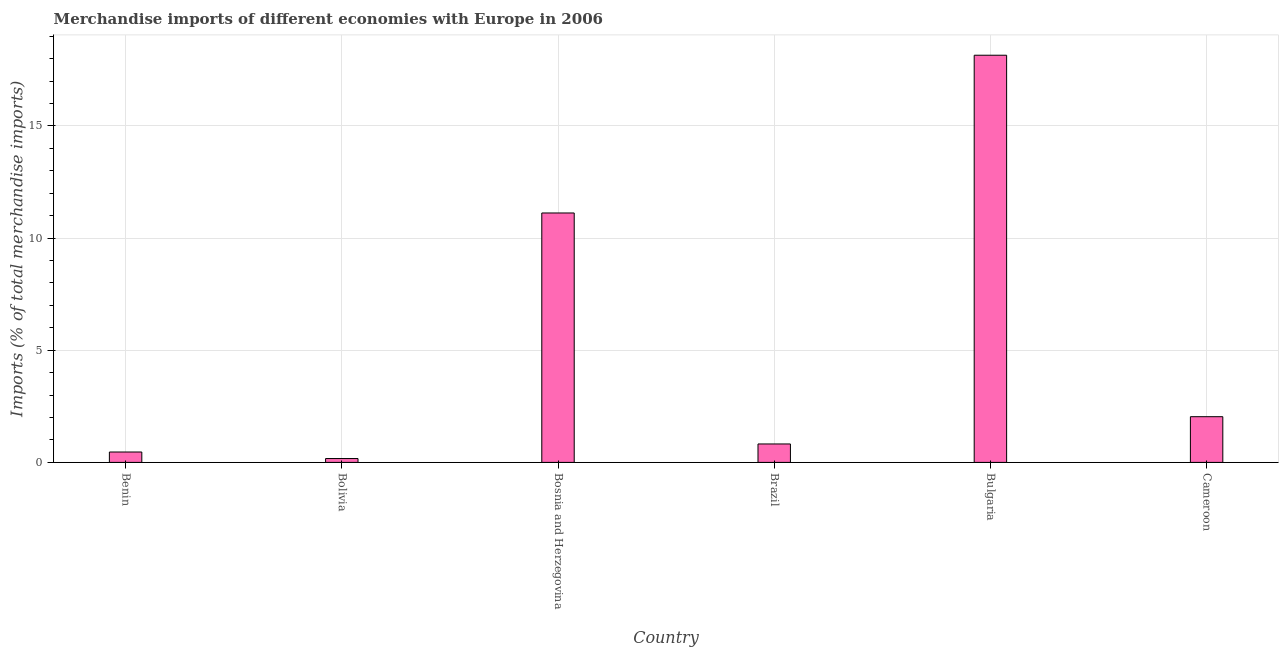What is the title of the graph?
Your response must be concise. Merchandise imports of different economies with Europe in 2006. What is the label or title of the X-axis?
Offer a very short reply. Country. What is the label or title of the Y-axis?
Keep it short and to the point. Imports (% of total merchandise imports). What is the merchandise imports in Bolivia?
Your answer should be very brief. 0.17. Across all countries, what is the maximum merchandise imports?
Make the answer very short. 18.15. Across all countries, what is the minimum merchandise imports?
Your answer should be very brief. 0.17. In which country was the merchandise imports maximum?
Your response must be concise. Bulgaria. What is the sum of the merchandise imports?
Make the answer very short. 32.77. What is the difference between the merchandise imports in Bolivia and Cameroon?
Your answer should be compact. -1.86. What is the average merchandise imports per country?
Provide a succinct answer. 5.46. What is the median merchandise imports?
Your answer should be very brief. 1.43. What is the ratio of the merchandise imports in Benin to that in Cameroon?
Provide a short and direct response. 0.23. What is the difference between the highest and the second highest merchandise imports?
Ensure brevity in your answer.  7.03. What is the difference between the highest and the lowest merchandise imports?
Provide a succinct answer. 17.98. In how many countries, is the merchandise imports greater than the average merchandise imports taken over all countries?
Provide a succinct answer. 2. How many bars are there?
Keep it short and to the point. 6. How many countries are there in the graph?
Ensure brevity in your answer.  6. Are the values on the major ticks of Y-axis written in scientific E-notation?
Give a very brief answer. No. What is the Imports (% of total merchandise imports) in Benin?
Your response must be concise. 0.46. What is the Imports (% of total merchandise imports) in Bolivia?
Offer a terse response. 0.17. What is the Imports (% of total merchandise imports) of Bosnia and Herzegovina?
Provide a succinct answer. 11.12. What is the Imports (% of total merchandise imports) in Brazil?
Keep it short and to the point. 0.82. What is the Imports (% of total merchandise imports) of Bulgaria?
Your answer should be very brief. 18.15. What is the Imports (% of total merchandise imports) of Cameroon?
Offer a terse response. 2.04. What is the difference between the Imports (% of total merchandise imports) in Benin and Bolivia?
Your answer should be compact. 0.29. What is the difference between the Imports (% of total merchandise imports) in Benin and Bosnia and Herzegovina?
Your response must be concise. -10.66. What is the difference between the Imports (% of total merchandise imports) in Benin and Brazil?
Give a very brief answer. -0.36. What is the difference between the Imports (% of total merchandise imports) in Benin and Bulgaria?
Your answer should be very brief. -17.69. What is the difference between the Imports (% of total merchandise imports) in Benin and Cameroon?
Your response must be concise. -1.57. What is the difference between the Imports (% of total merchandise imports) in Bolivia and Bosnia and Herzegovina?
Your answer should be very brief. -10.95. What is the difference between the Imports (% of total merchandise imports) in Bolivia and Brazil?
Provide a succinct answer. -0.65. What is the difference between the Imports (% of total merchandise imports) in Bolivia and Bulgaria?
Ensure brevity in your answer.  -17.98. What is the difference between the Imports (% of total merchandise imports) in Bolivia and Cameroon?
Keep it short and to the point. -1.87. What is the difference between the Imports (% of total merchandise imports) in Bosnia and Herzegovina and Brazil?
Offer a very short reply. 10.3. What is the difference between the Imports (% of total merchandise imports) in Bosnia and Herzegovina and Bulgaria?
Provide a succinct answer. -7.03. What is the difference between the Imports (% of total merchandise imports) in Bosnia and Herzegovina and Cameroon?
Provide a short and direct response. 9.08. What is the difference between the Imports (% of total merchandise imports) in Brazil and Bulgaria?
Provide a short and direct response. -17.33. What is the difference between the Imports (% of total merchandise imports) in Brazil and Cameroon?
Offer a very short reply. -1.22. What is the difference between the Imports (% of total merchandise imports) in Bulgaria and Cameroon?
Your response must be concise. 16.11. What is the ratio of the Imports (% of total merchandise imports) in Benin to that in Bolivia?
Provide a succinct answer. 2.69. What is the ratio of the Imports (% of total merchandise imports) in Benin to that in Bosnia and Herzegovina?
Your answer should be compact. 0.04. What is the ratio of the Imports (% of total merchandise imports) in Benin to that in Brazil?
Provide a succinct answer. 0.56. What is the ratio of the Imports (% of total merchandise imports) in Benin to that in Bulgaria?
Offer a very short reply. 0.03. What is the ratio of the Imports (% of total merchandise imports) in Benin to that in Cameroon?
Give a very brief answer. 0.23. What is the ratio of the Imports (% of total merchandise imports) in Bolivia to that in Bosnia and Herzegovina?
Provide a succinct answer. 0.01. What is the ratio of the Imports (% of total merchandise imports) in Bolivia to that in Brazil?
Offer a terse response. 0.21. What is the ratio of the Imports (% of total merchandise imports) in Bolivia to that in Bulgaria?
Keep it short and to the point. 0.01. What is the ratio of the Imports (% of total merchandise imports) in Bolivia to that in Cameroon?
Offer a very short reply. 0.09. What is the ratio of the Imports (% of total merchandise imports) in Bosnia and Herzegovina to that in Brazil?
Keep it short and to the point. 13.53. What is the ratio of the Imports (% of total merchandise imports) in Bosnia and Herzegovina to that in Bulgaria?
Your answer should be very brief. 0.61. What is the ratio of the Imports (% of total merchandise imports) in Bosnia and Herzegovina to that in Cameroon?
Offer a very short reply. 5.46. What is the ratio of the Imports (% of total merchandise imports) in Brazil to that in Bulgaria?
Keep it short and to the point. 0.04. What is the ratio of the Imports (% of total merchandise imports) in Brazil to that in Cameroon?
Your response must be concise. 0.4. What is the ratio of the Imports (% of total merchandise imports) in Bulgaria to that in Cameroon?
Offer a terse response. 8.91. 